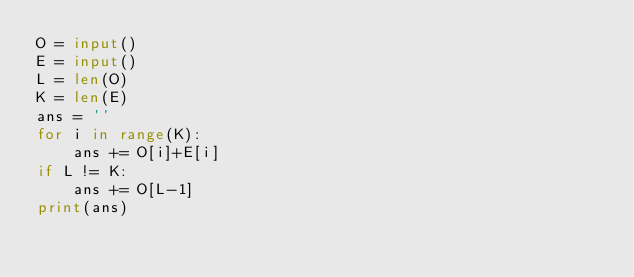Convert code to text. <code><loc_0><loc_0><loc_500><loc_500><_Python_>O = input()
E = input()
L = len(O)
K = len(E)
ans = ''
for i in range(K):
    ans += O[i]+E[i]
if L != K:
    ans += O[L-1]
print(ans)</code> 